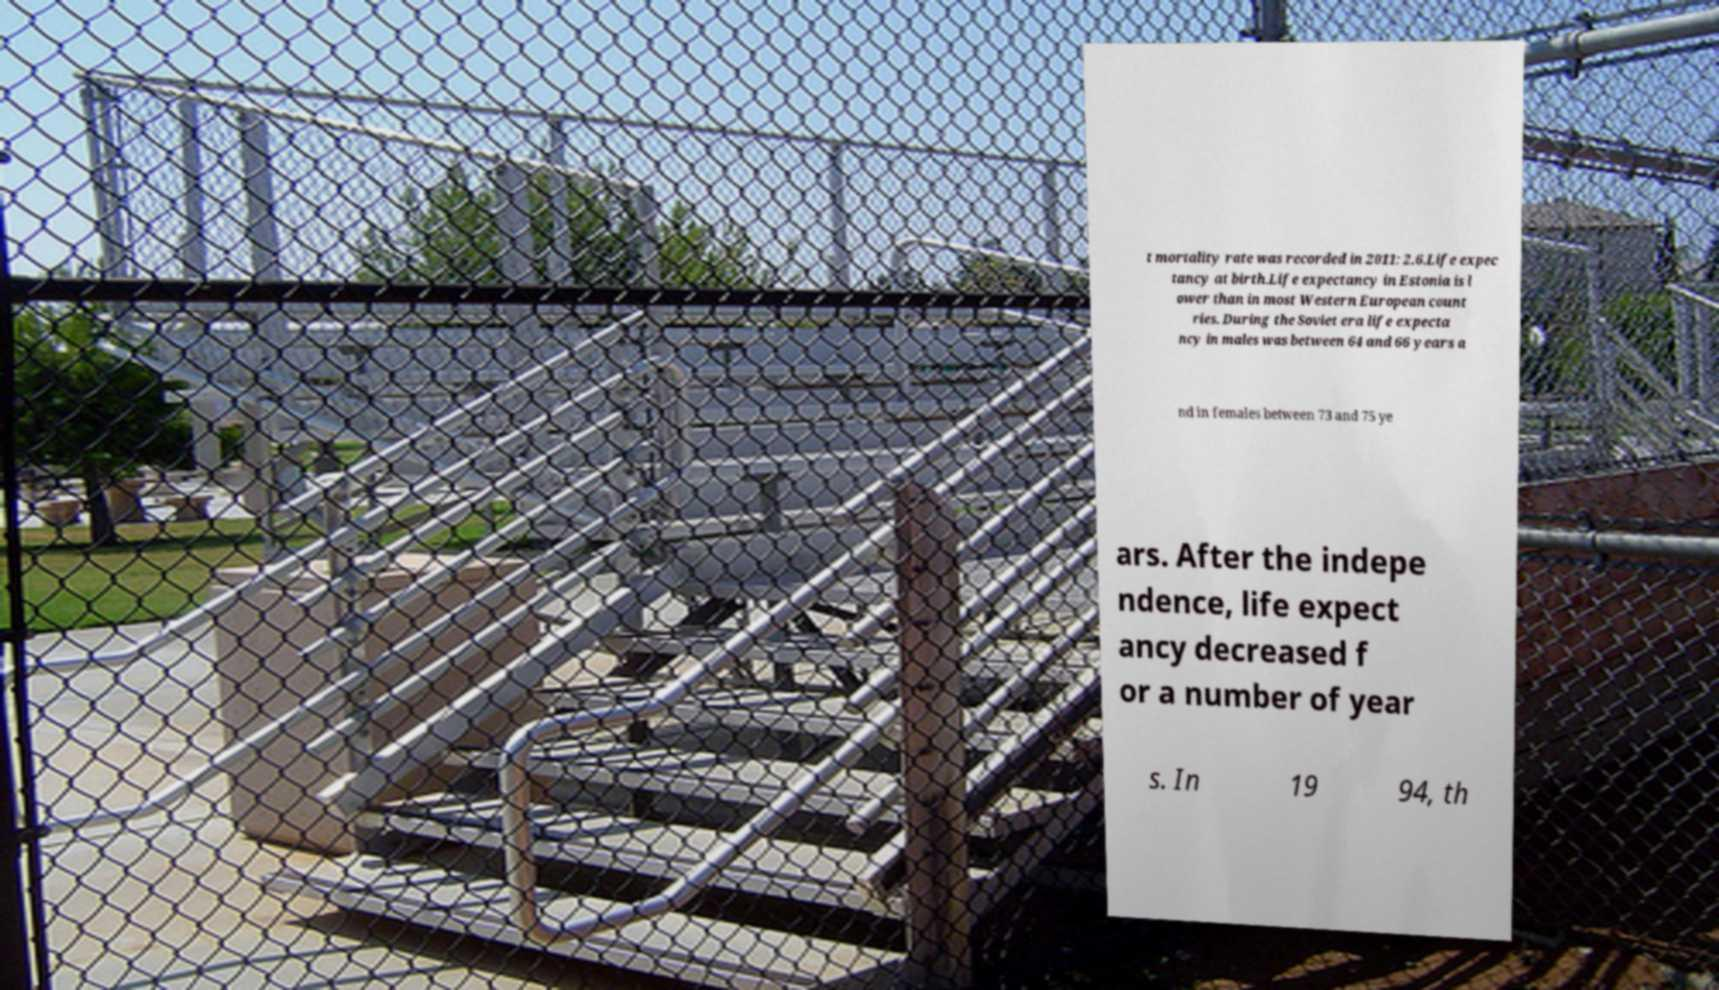Please identify and transcribe the text found in this image. t mortality rate was recorded in 2011: 2.6.Life expec tancy at birth.Life expectancy in Estonia is l ower than in most Western European count ries. During the Soviet era life expecta ncy in males was between 64 and 66 years a nd in females between 73 and 75 ye ars. After the indepe ndence, life expect ancy decreased f or a number of year s. In 19 94, th 